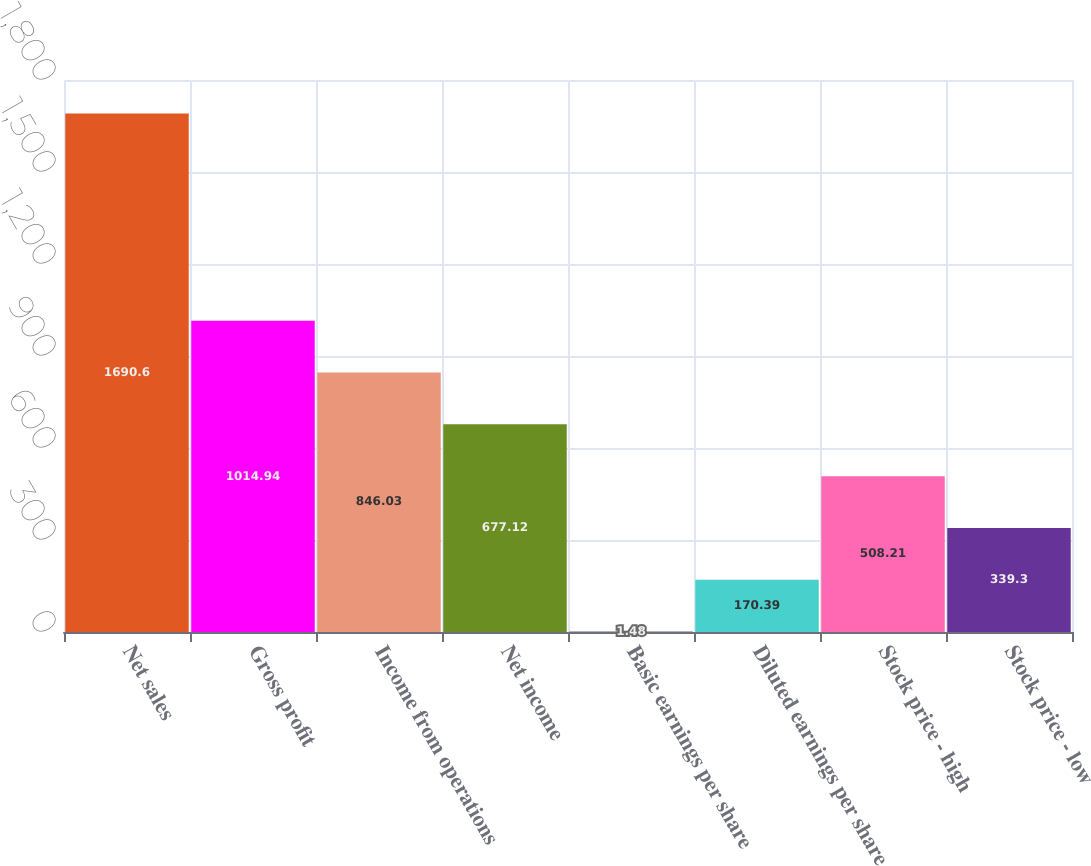<chart> <loc_0><loc_0><loc_500><loc_500><bar_chart><fcel>Net sales<fcel>Gross profit<fcel>Income from operations<fcel>Net income<fcel>Basic earnings per share<fcel>Diluted earnings per share<fcel>Stock price - high<fcel>Stock price - low<nl><fcel>1690.6<fcel>1014.94<fcel>846.03<fcel>677.12<fcel>1.48<fcel>170.39<fcel>508.21<fcel>339.3<nl></chart> 